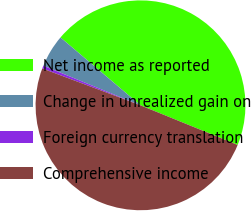<chart> <loc_0><loc_0><loc_500><loc_500><pie_chart><fcel>Net income as reported<fcel>Change in unrealized gain on<fcel>Foreign currency translation<fcel>Comprehensive income<nl><fcel>44.97%<fcel>5.03%<fcel>0.45%<fcel>49.55%<nl></chart> 